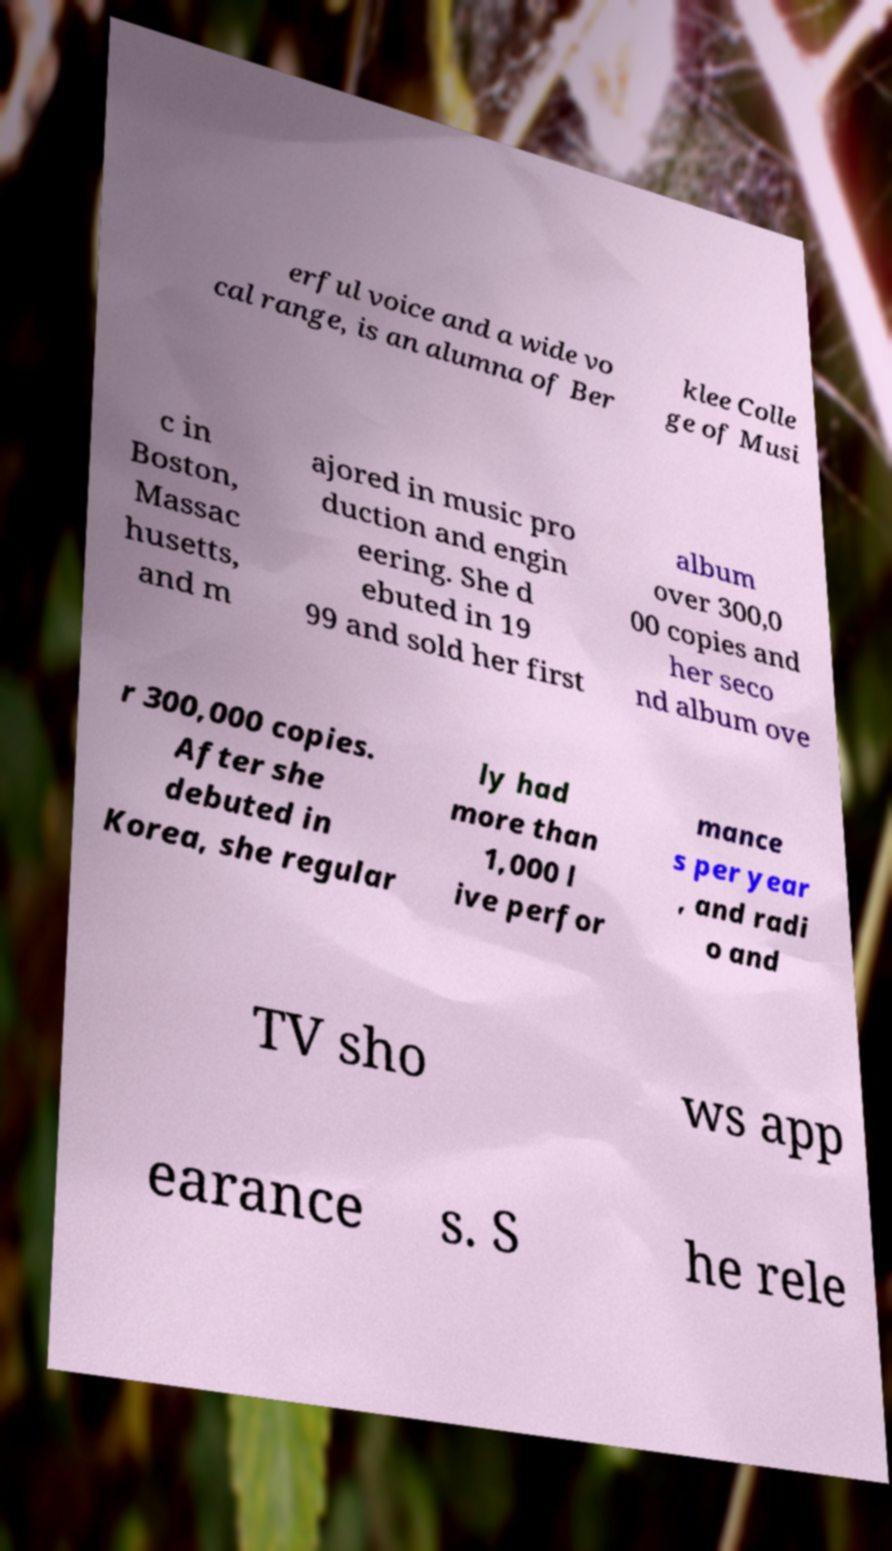I need the written content from this picture converted into text. Can you do that? erful voice and a wide vo cal range, is an alumna of Ber klee Colle ge of Musi c in Boston, Massac husetts, and m ajored in music pro duction and engin eering. She d ebuted in 19 99 and sold her first album over 300,0 00 copies and her seco nd album ove r 300,000 copies. After she debuted in Korea, she regular ly had more than 1,000 l ive perfor mance s per year , and radi o and TV sho ws app earance s. S he rele 